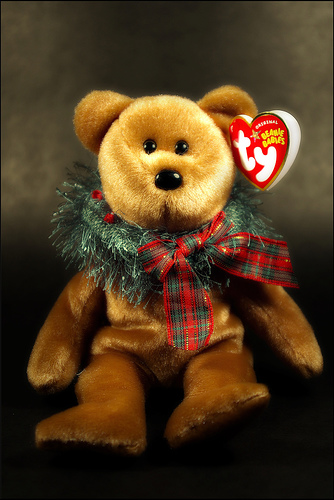<image>
Can you confirm if the ribbon is next to the teddy bear? Yes. The ribbon is positioned adjacent to the teddy bear, located nearby in the same general area. 